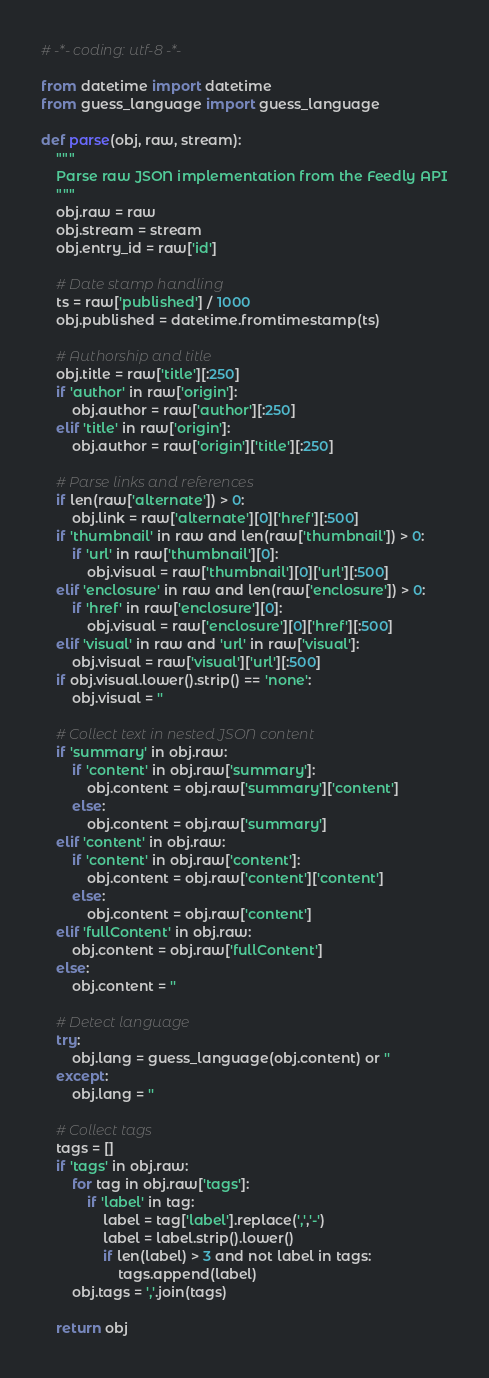Convert code to text. <code><loc_0><loc_0><loc_500><loc_500><_Python_># -*- coding: utf-8 -*-

from datetime import datetime
from guess_language import guess_language

def parse(obj, raw, stream):
    """
    Parse raw JSON implementation from the Feedly API
    """
    obj.raw = raw
    obj.stream = stream
    obj.entry_id = raw['id']

    # Date stamp handling
    ts = raw['published'] / 1000
    obj.published = datetime.fromtimestamp(ts)

    # Authorship and title
    obj.title = raw['title'][:250]
    if 'author' in raw['origin']:
        obj.author = raw['author'][:250]
    elif 'title' in raw['origin']:
        obj.author = raw['origin']['title'][:250]

    # Parse links and references
    if len(raw['alternate']) > 0:
        obj.link = raw['alternate'][0]['href'][:500]
    if 'thumbnail' in raw and len(raw['thumbnail']) > 0:
        if 'url' in raw['thumbnail'][0]:
            obj.visual = raw['thumbnail'][0]['url'][:500]
    elif 'enclosure' in raw and len(raw['enclosure']) > 0:
        if 'href' in raw['enclosure'][0]:
            obj.visual = raw['enclosure'][0]['href'][:500]
    elif 'visual' in raw and 'url' in raw['visual']:
        obj.visual = raw['visual']['url'][:500]
    if obj.visual.lower().strip() == 'none':
        obj.visual = ''

    # Collect text in nested JSON content
    if 'summary' in obj.raw:
        if 'content' in obj.raw['summary']:
            obj.content = obj.raw['summary']['content']
        else:
            obj.content = obj.raw['summary']
    elif 'content' in obj.raw:
        if 'content' in obj.raw['content']:
            obj.content = obj.raw['content']['content']
        else:
            obj.content = obj.raw['content']
    elif 'fullContent' in obj.raw:
        obj.content = obj.raw['fullContent']
    else:
        obj.content = ''

    # Detect language
    try:
        obj.lang = guess_language(obj.content) or ''
    except:
        obj.lang = ''

    # Collect tags
    tags = []
    if 'tags' in obj.raw:
        for tag in obj.raw['tags']:
            if 'label' in tag:
                label = tag['label'].replace(',','-')
                label = label.strip().lower()
                if len(label) > 3 and not label in tags:
                    tags.append(label)
        obj.tags = ','.join(tags)

    return obj
</code> 